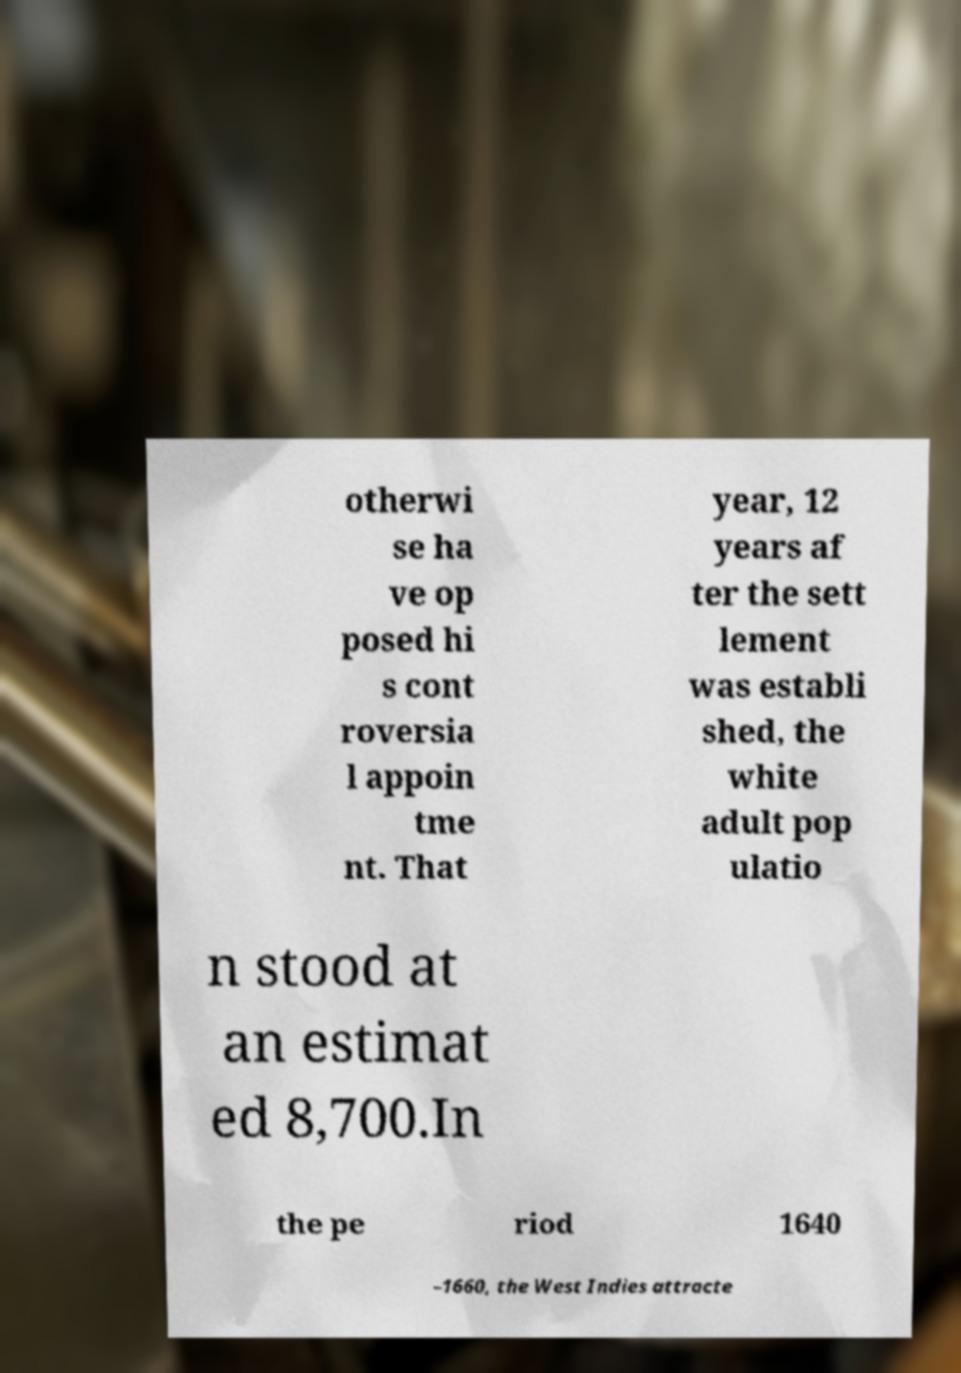Could you extract and type out the text from this image? otherwi se ha ve op posed hi s cont roversia l appoin tme nt. That year, 12 years af ter the sett lement was establi shed, the white adult pop ulatio n stood at an estimat ed 8,700.In the pe riod 1640 –1660, the West Indies attracte 